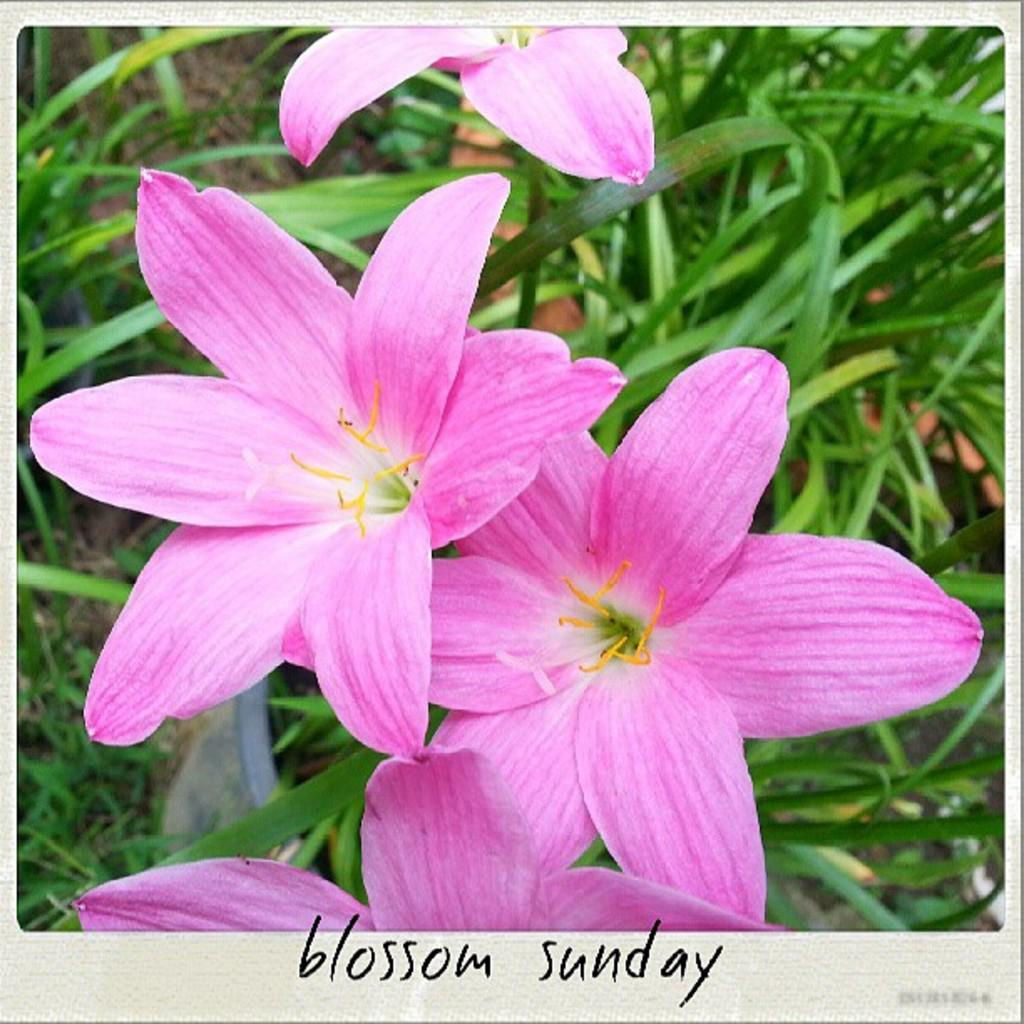What is the main subject of the poster in the image? The poster contains images of flowers. Are there any other elements on the poster besides the flower images? Yes, there is text at the bottom of the poster. What can be seen in the background of the image? There are plants visible in the background of the image. Can you describe the face of the person in the image? There is no person present in the image, only a poster with flower images and text. What type of lock is used to secure the poster in the image? There is no lock visible in the image; it only shows a poster with flower images and text. 